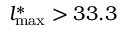<formula> <loc_0><loc_0><loc_500><loc_500>l _ { \max } ^ { \ast } > 3 3 . 3</formula> 